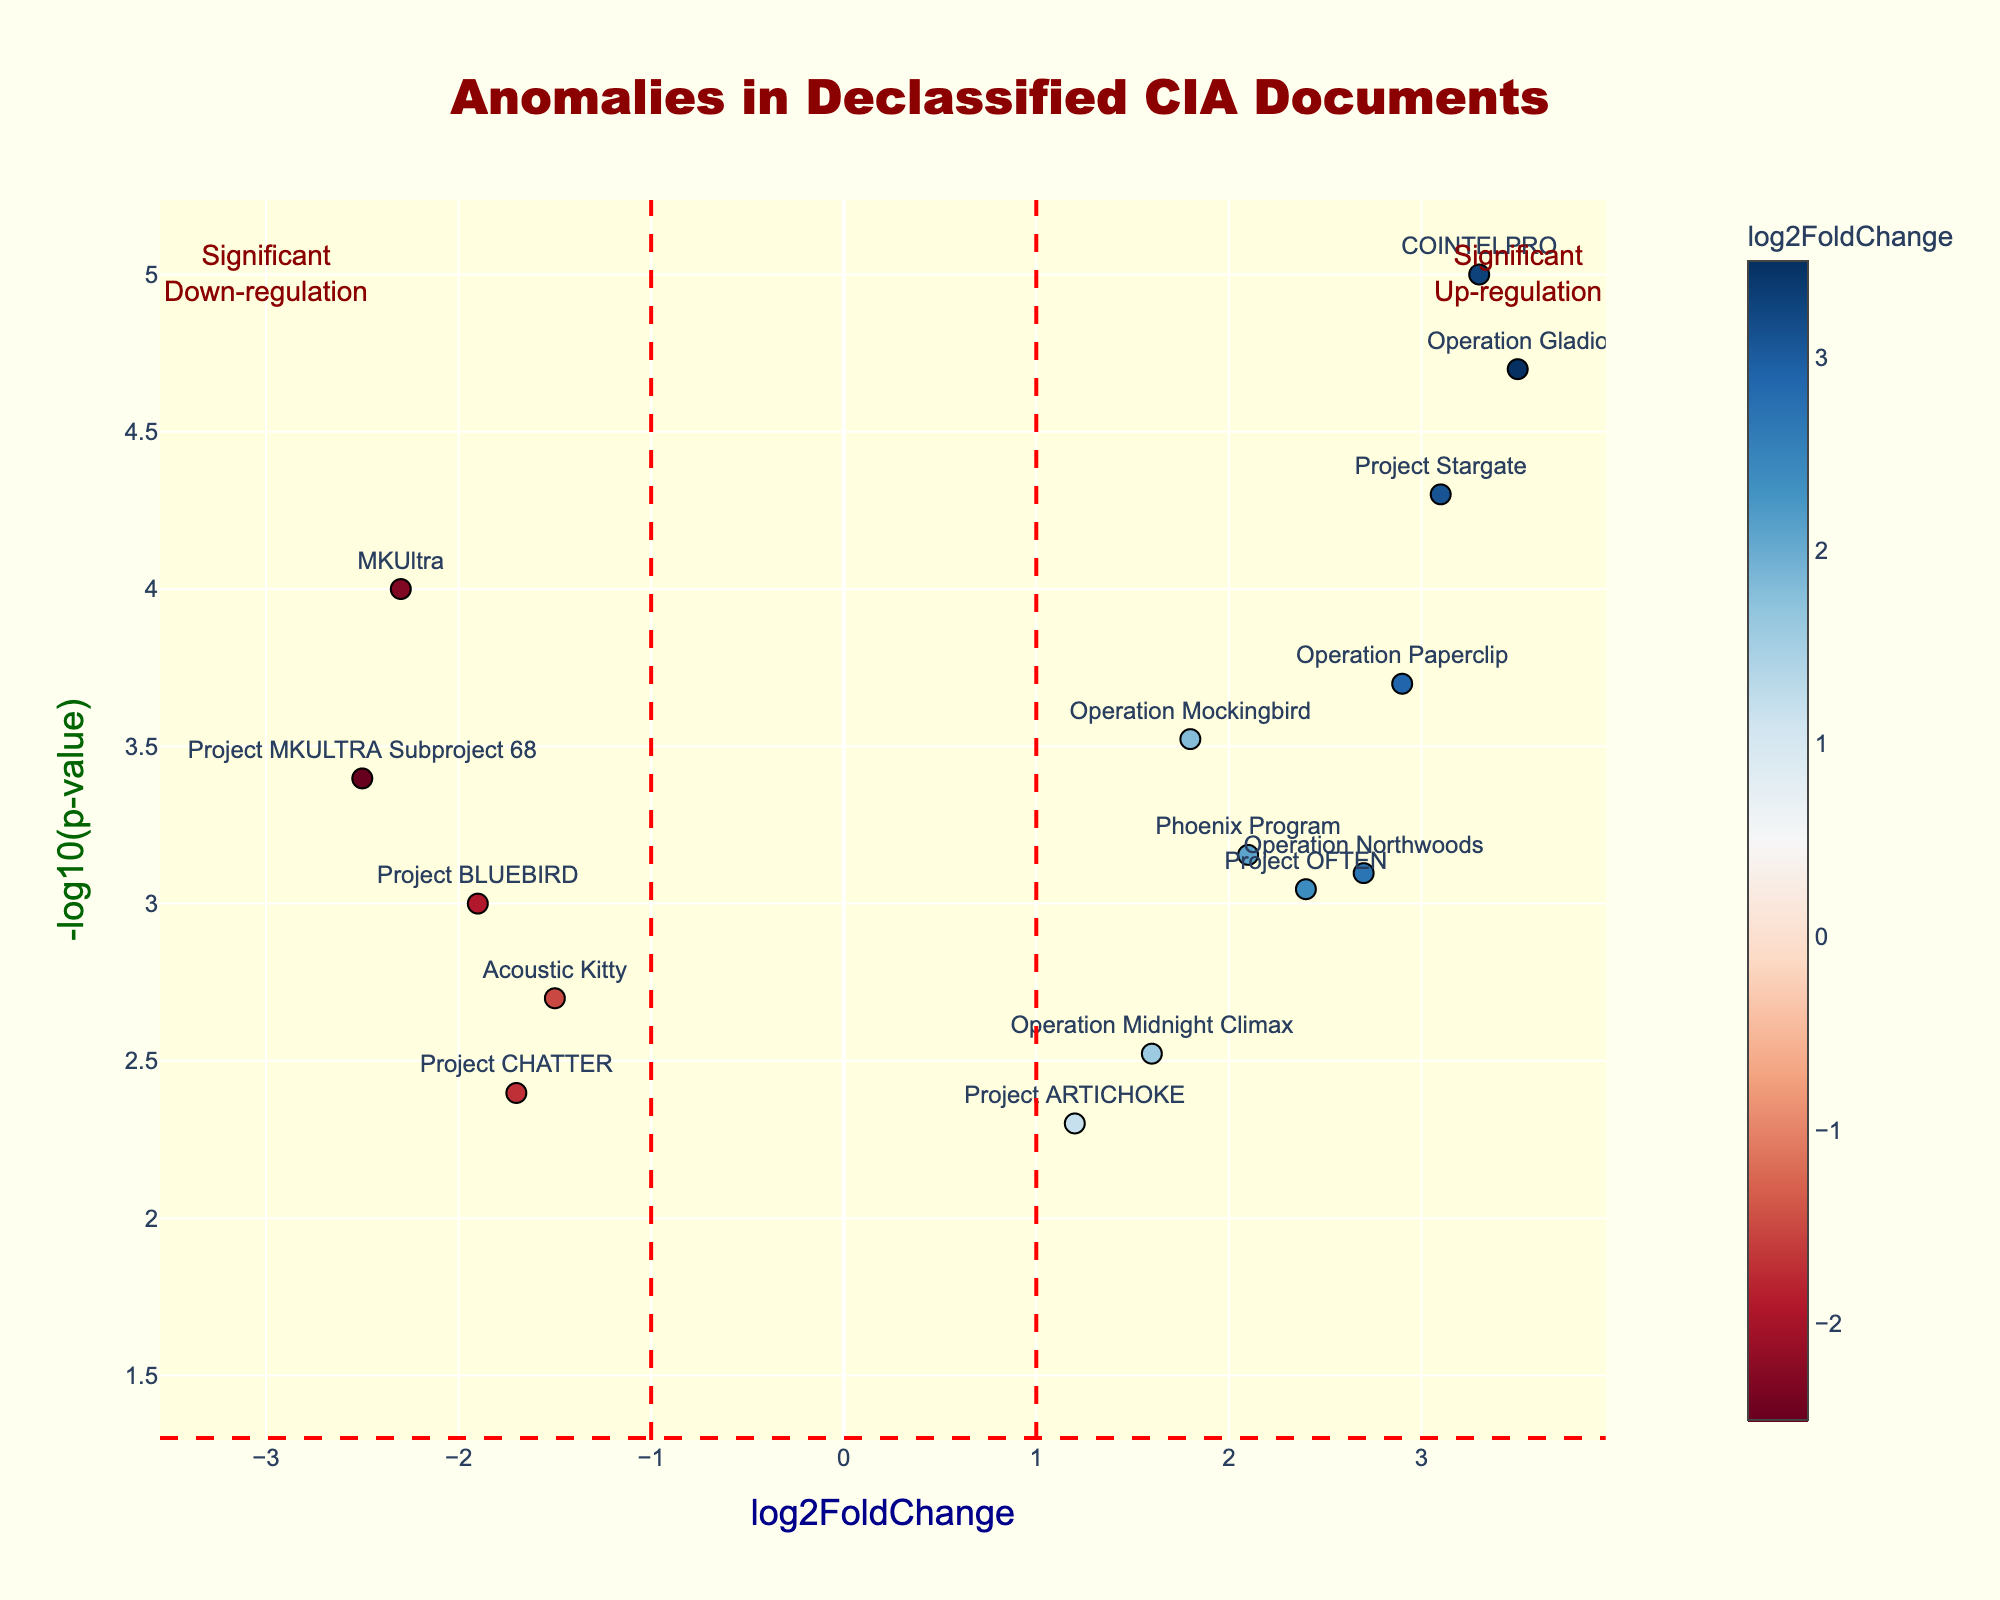how many terms are present in the figure? Count the number of data points shown, each representing a term. Since there are 14 points, this indicates 14 terms.
Answer: 14 what does the x-axis represent? The x-axis is labeled "log2FoldChange," which measures the logarithm base 2 of the fold change of word frequencies between two sets.
Answer: log2FoldChange which term has the highest log2FoldChange and what is it? Look for the data point farthest to the right on the x-axis. The term is "Operation Gladio," with a log2FoldChange of 3.5.
Answer: Operation Gladio, 3.5 which term has the lowest p-value and what is it? Determine the point with the highest -log10(p-value) along the y-axis. "COINTELPRO" has the highest -log10(p-value), indicating the lowest p-value of 0.00001.
Answer: COINTELPRO, 0.00001 which terms are significantly up-regulated? For terms to be significantly up-regulated, they must be above the horizontal red line at y = -log10(0.05) and to the right of the vertical red line at x = 1. The terms are: "Operation Mockingbird," "Project Stargate," "Operation Northwoods," "Operation Paperclip," "COINTELPRO," "Phoenix Program," "Operation Midnight Climax," "Project OFTEN," and "Operation Gladio."
Answer: Operation Mockingbird, Project Stargate, Operation Northwoods, Operation Paperclip, COINTELPRO, Phoenix Program, Operation Midnight Climax, Project OFTEN, Operation Gladio which term is closest to the origin (0,0)? Find the data point nearest to the intersection of the x-axis and y-axis (0,0). "Project ARTICHOKE" has the closest coordinates to 0,0.
Answer: Project ARTICHOKE are any terms both significantly up-regulated and have a -log10(p-value) greater than 4? Identify terms that meet both criteria of being right of the vertical red line at x = 1 and above the y = 4 line. The terms are: "COINTELPRO" and "Operation Gladio."
Answer: COINTELPRO, Operation Gladio compare the log2FoldChange values of "MKUltra" and "Project Stargate." which is greater? Locate the log2FoldChange value for each term. "MKUltra" is -2.3, and "Project Stargate" is 3.1. Therefore, "Project Stargate" has a greater log2FoldChange.
Answer: Project Stargate 